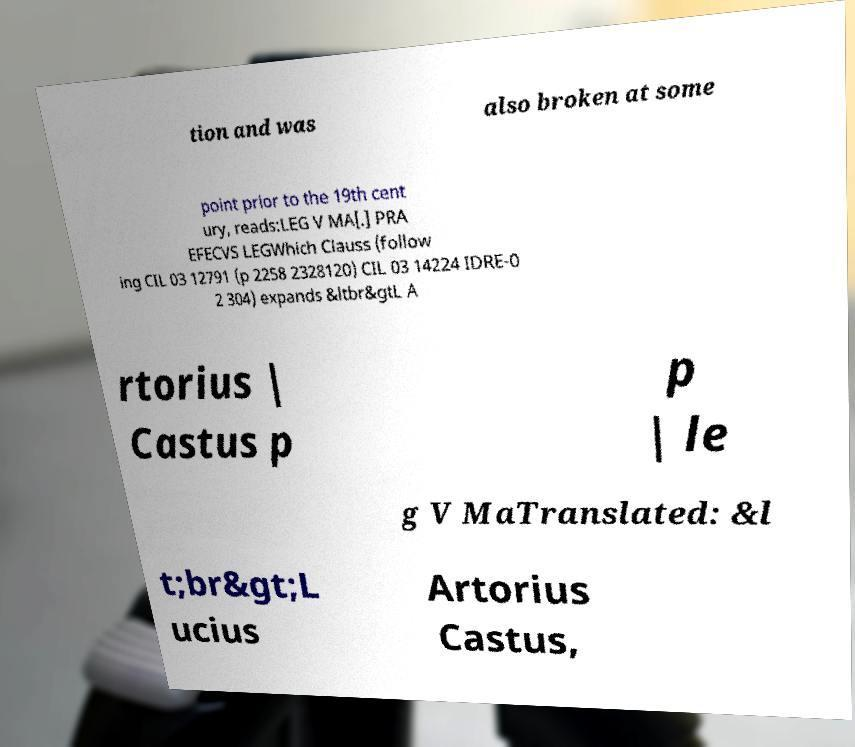There's text embedded in this image that I need extracted. Can you transcribe it verbatim? tion and was also broken at some point prior to the 19th cent ury, reads:LEG V MA[.] PRA EFECVS LEGWhich Clauss (follow ing CIL 03 12791 (p 2258 2328120) CIL 03 14224 IDRE-0 2 304) expands &ltbr&gtL A rtorius | Castus p p | le g V MaTranslated: &l t;br&gt;L ucius Artorius Castus, 